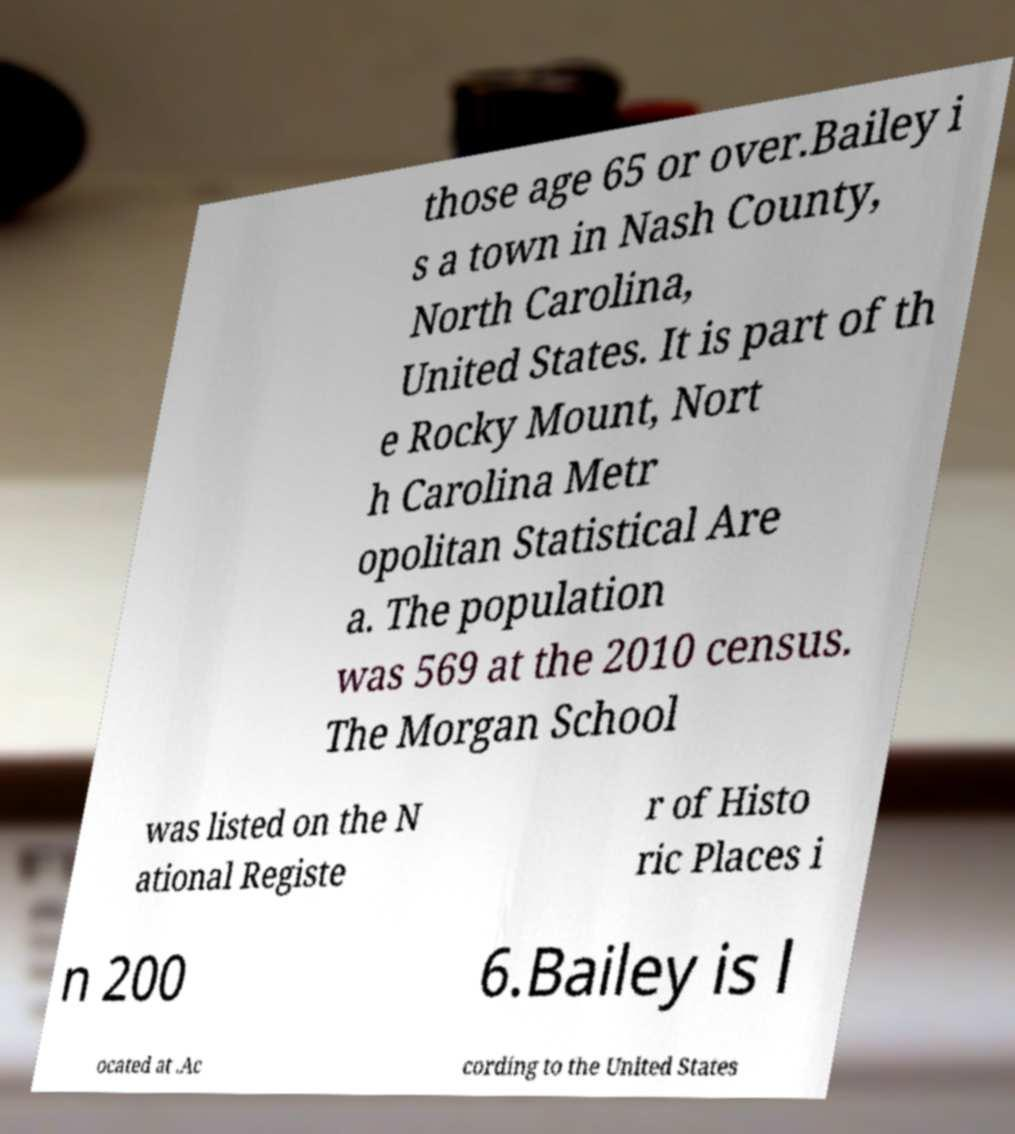For documentation purposes, I need the text within this image transcribed. Could you provide that? those age 65 or over.Bailey i s a town in Nash County, North Carolina, United States. It is part of th e Rocky Mount, Nort h Carolina Metr opolitan Statistical Are a. The population was 569 at the 2010 census. The Morgan School was listed on the N ational Registe r of Histo ric Places i n 200 6.Bailey is l ocated at .Ac cording to the United States 